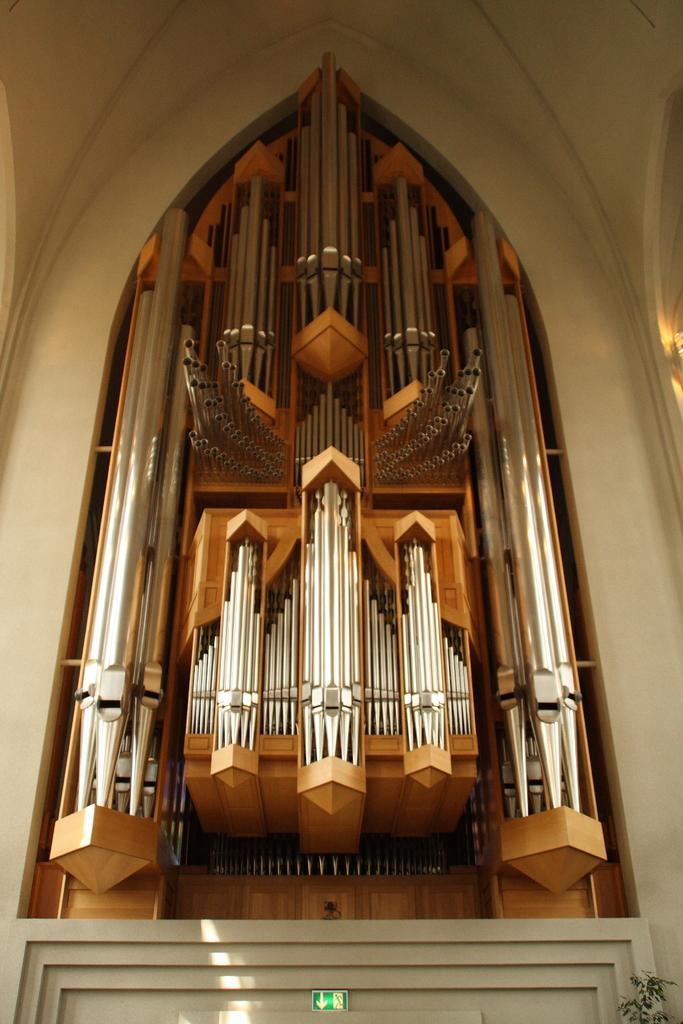In one or two sentences, can you explain what this image depicts? In this image in the center there are objects and some metal rods, and in the background there is wall. At the bottom there is a sign board and plant. 